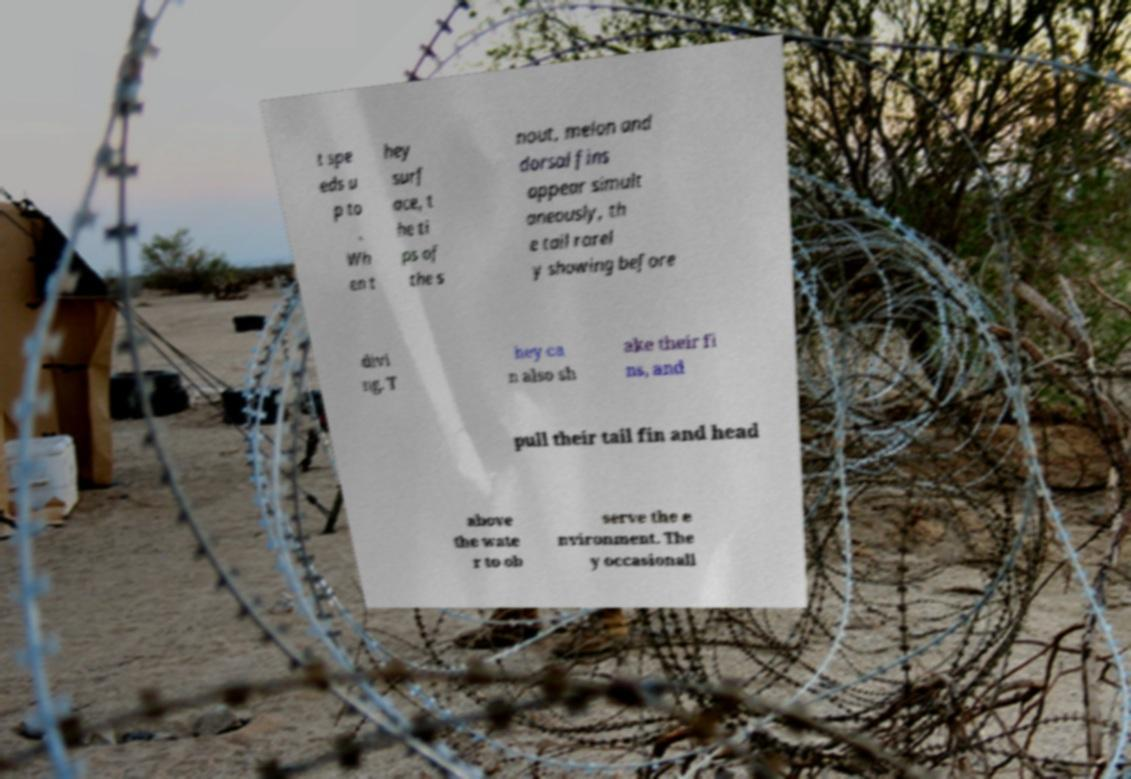Could you extract and type out the text from this image? t spe eds u p to . Wh en t hey surf ace, t he ti ps of the s nout, melon and dorsal fins appear simult aneously, th e tail rarel y showing before divi ng. T hey ca n also sh ake their fi ns, and pull their tail fin and head above the wate r to ob serve the e nvironment. The y occasionall 